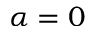Convert formula to latex. <formula><loc_0><loc_0><loc_500><loc_500>\alpha = 0</formula> 